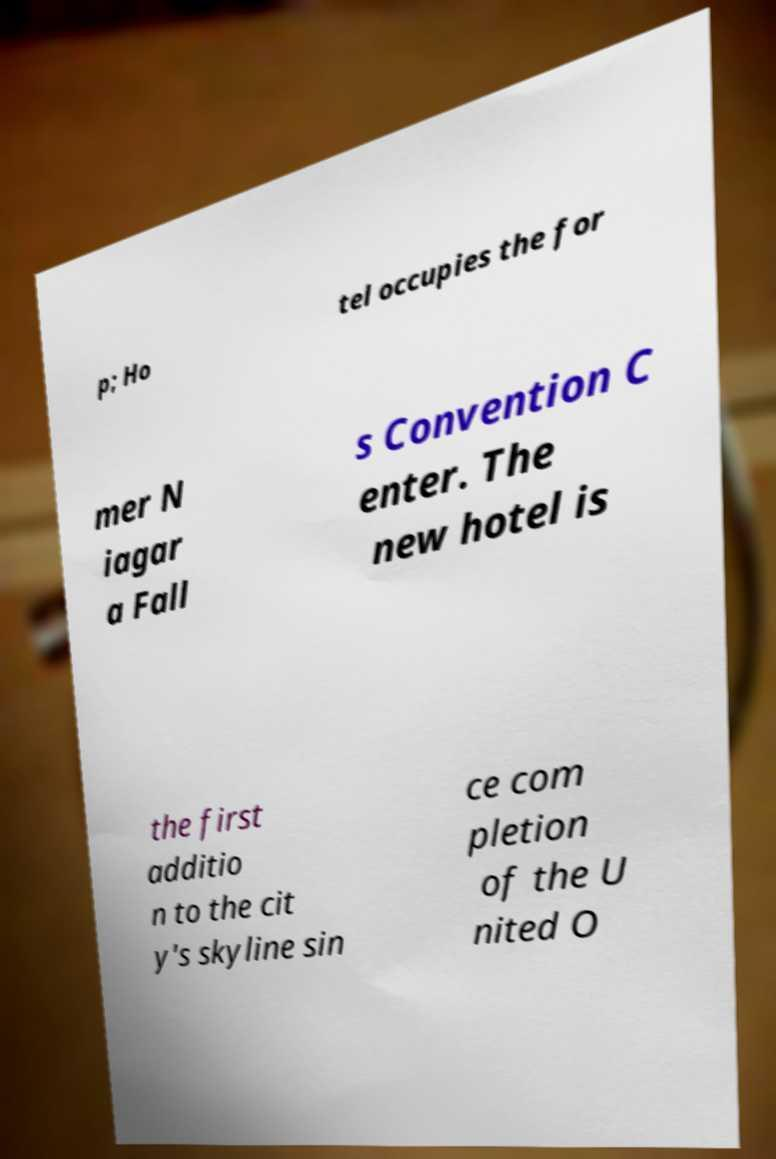Please identify and transcribe the text found in this image. p; Ho tel occupies the for mer N iagar a Fall s Convention C enter. The new hotel is the first additio n to the cit y's skyline sin ce com pletion of the U nited O 